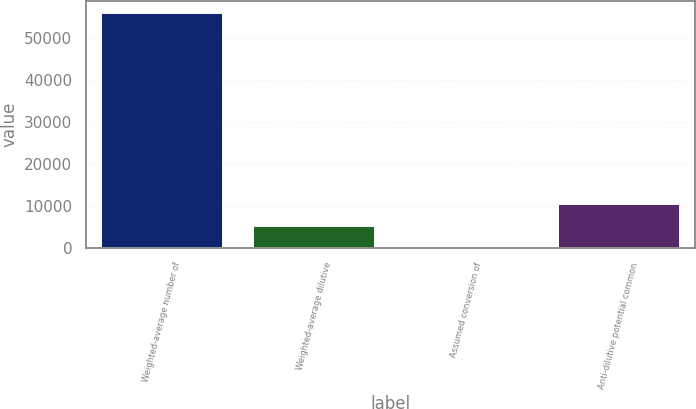Convert chart to OTSL. <chart><loc_0><loc_0><loc_500><loc_500><bar_chart><fcel>Weighted-average number of<fcel>Weighted-average dilutive<fcel>Assumed conversion of<fcel>Anti-dilutive potential common<nl><fcel>56073.5<fcel>5391.5<fcel>258<fcel>10525<nl></chart> 